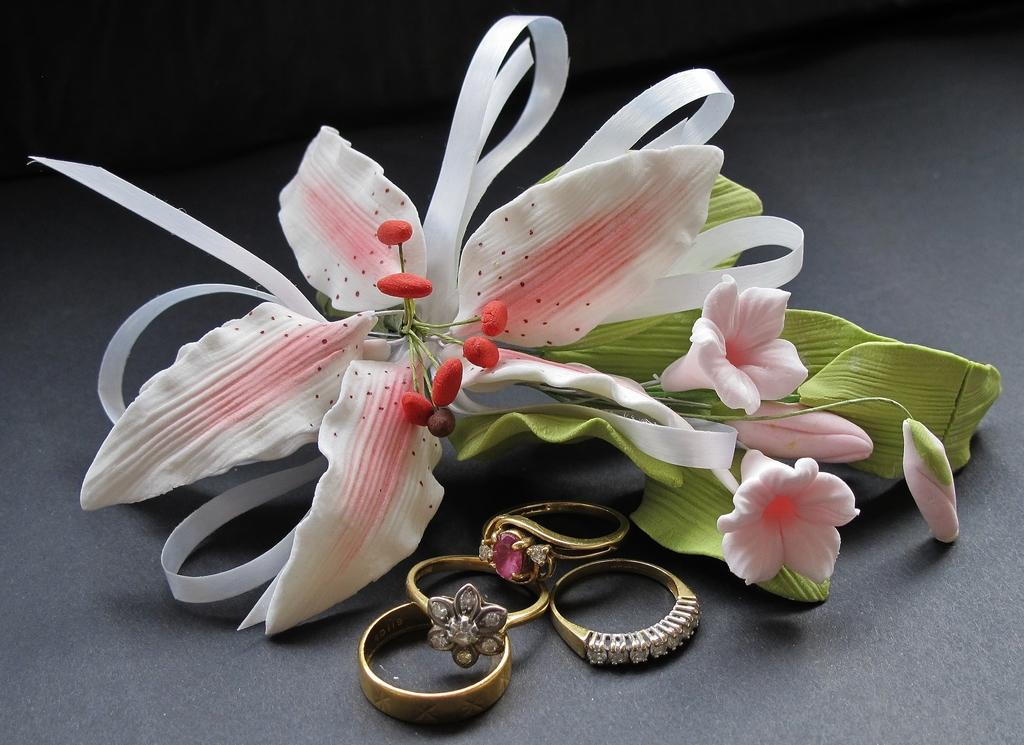What type of objects can be seen in the image? There are rings and flowers in the image. What is the color of the surface in the image? The surface in the image is black. What language is spoken by the people inside the church in the image? There is no church or people present in the image, so it is not possible to determine what language might be spoken. 